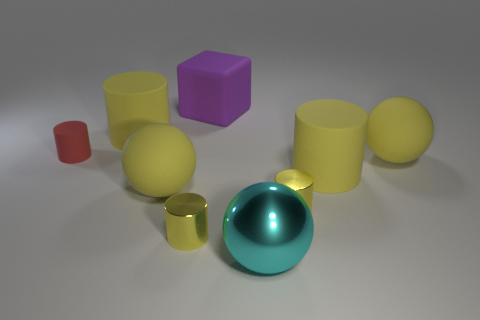How many yellow spheres must be subtracted to get 1 yellow spheres? 1 Subtract all cyan blocks. How many yellow cylinders are left? 4 Subtract 1 cylinders. How many cylinders are left? 4 Subtract all red cylinders. How many cylinders are left? 4 Subtract all matte balls. How many balls are left? 1 Add 1 yellow spheres. How many objects exist? 10 Subtract all purple cylinders. Subtract all purple balls. How many cylinders are left? 5 Subtract all cylinders. How many objects are left? 4 Subtract all cyan balls. Subtract all yellow rubber cylinders. How many objects are left? 6 Add 4 large cyan spheres. How many large cyan spheres are left? 5 